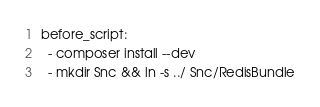Convert code to text. <code><loc_0><loc_0><loc_500><loc_500><_YAML_>before_script:
  - composer install --dev
  - mkdir Snc && ln -s ../ Snc/RedisBundle
</code> 